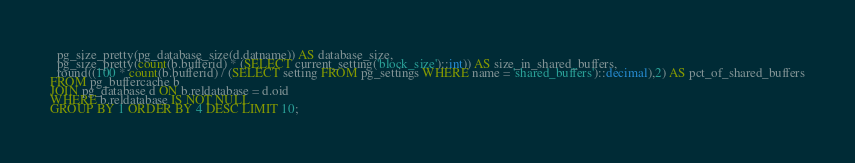Convert code to text. <code><loc_0><loc_0><loc_500><loc_500><_SQL_>  pg_size_pretty(pg_database_size(d.datname)) AS database_size,
  pg_size_pretty(count(b.bufferid) * (SELECT current_setting('block_size')::int)) AS size_in_shared_buffers,
  round((100 * count(b.bufferid) / (SELECT setting FROM pg_settings WHERE name = 'shared_buffers')::decimal),2) AS pct_of_shared_buffers
FROM pg_buffercache b
JOIN pg_database d ON b.reldatabase = d.oid
WHERE b.reldatabase IS NOT NULL
GROUP BY 1 ORDER BY 4 DESC LIMIT 10;
</code> 